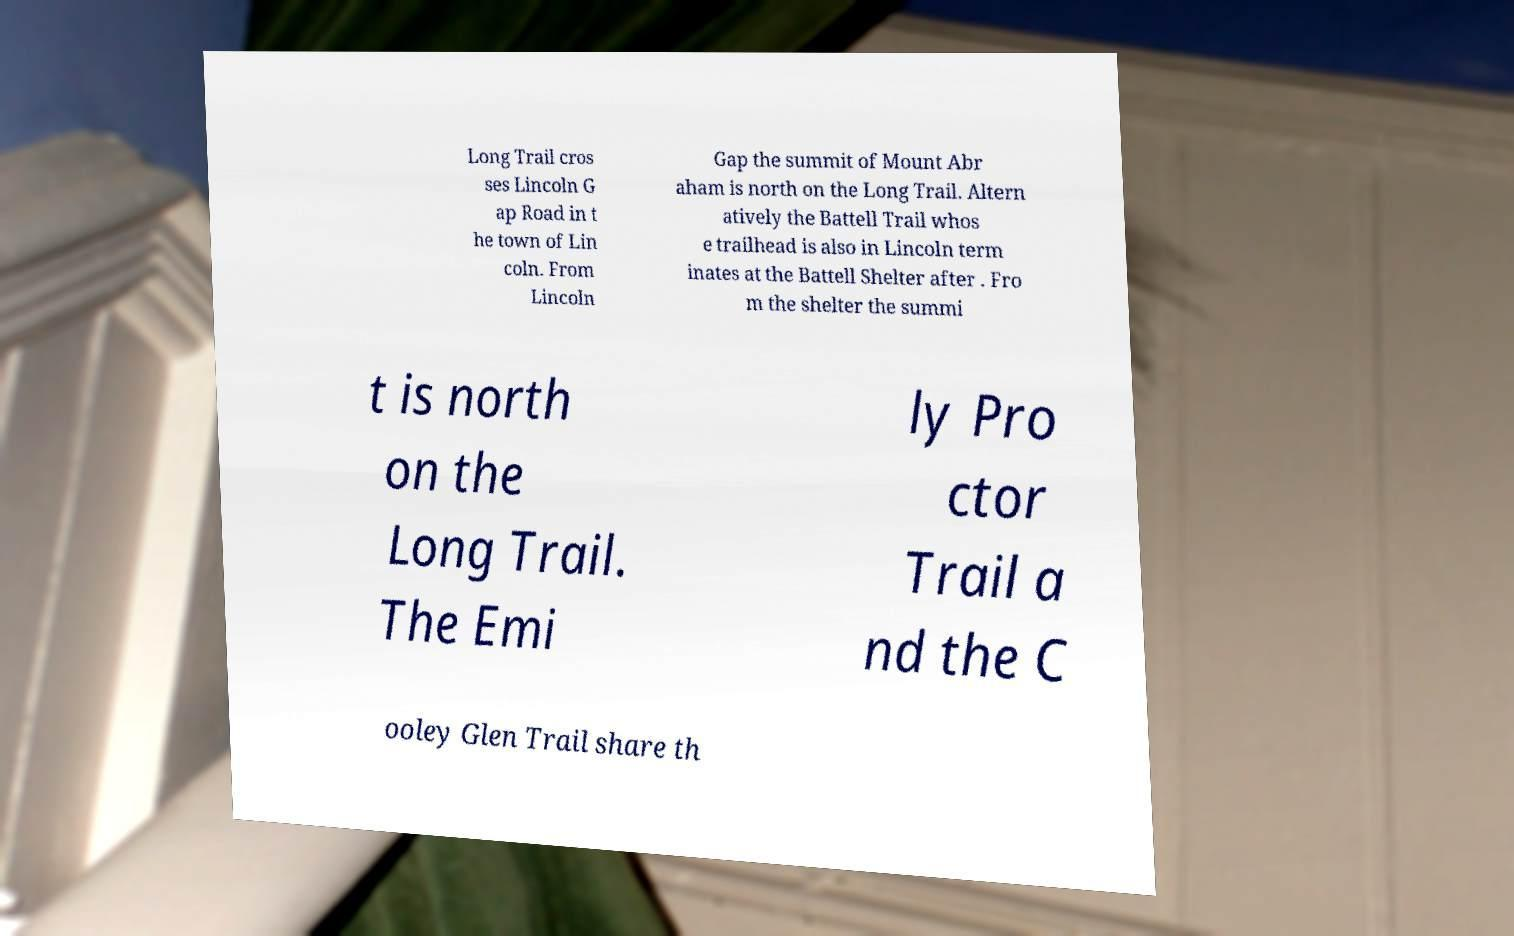Please identify and transcribe the text found in this image. Long Trail cros ses Lincoln G ap Road in t he town of Lin coln. From Lincoln Gap the summit of Mount Abr aham is north on the Long Trail. Altern atively the Battell Trail whos e trailhead is also in Lincoln term inates at the Battell Shelter after . Fro m the shelter the summi t is north on the Long Trail. The Emi ly Pro ctor Trail a nd the C ooley Glen Trail share th 